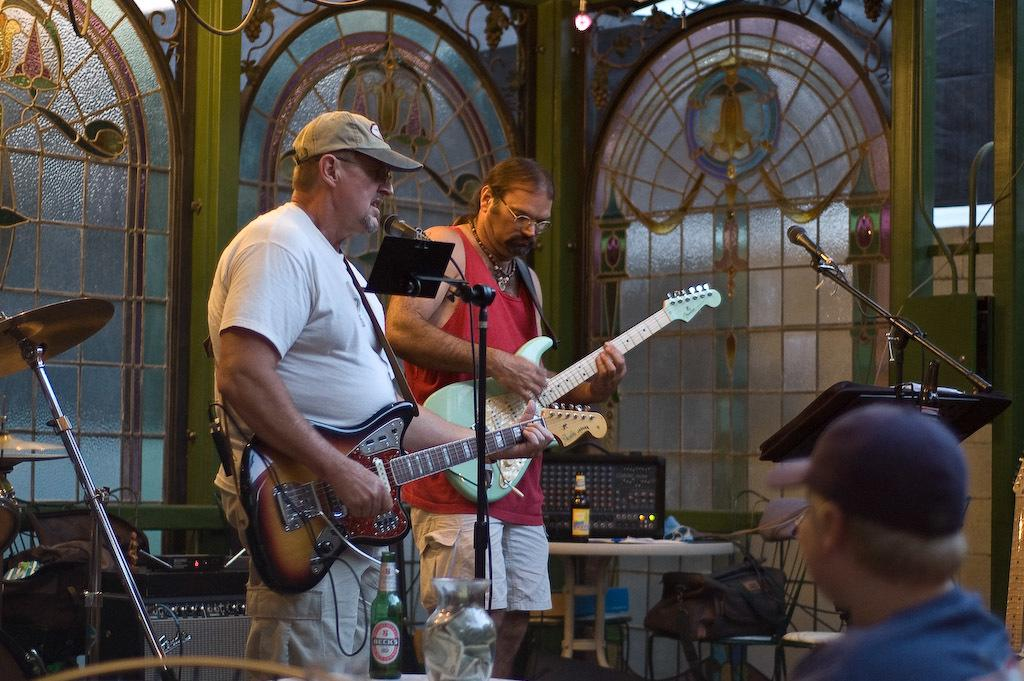What are the people in the image doing? The group of persons in the image are playing musical instruments. What might be used to amplify the sound of their instruments? There are microphones in front of the group of persons, which might be used to amplify the sound. What can be seen in the background of the image? There are doors visible in the background of the image. What type of ink is being used by the group of persons to read a book in the image? There is no book or ink present in the image; the group of persons is playing musical instruments. 